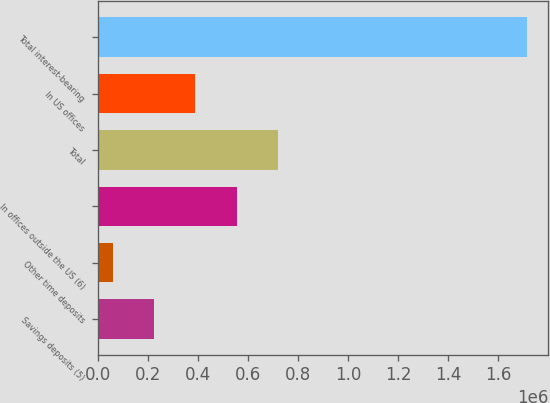Convert chart. <chart><loc_0><loc_0><loc_500><loc_500><bar_chart><fcel>Savings deposits (5)<fcel>Other time deposits<fcel>In offices outside the US (6)<fcel>Total<fcel>In US offices<fcel>Total interest-bearing<nl><fcel>224313<fcel>58808<fcel>555322<fcel>720826<fcel>389817<fcel>1.71385e+06<nl></chart> 